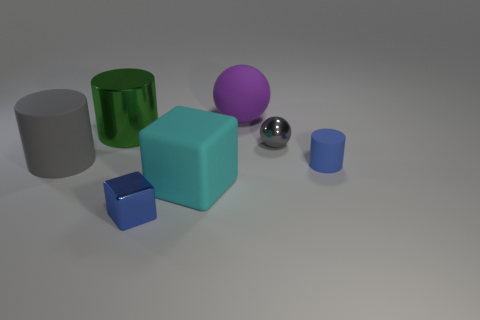Can you describe the colors of the objects in the image? Certainly! In the image, there is a variety of colored objects including a green cylinder, a purple sphere, a blue cube, a blue cylinder, a gray cylinder, and a gray ball. 